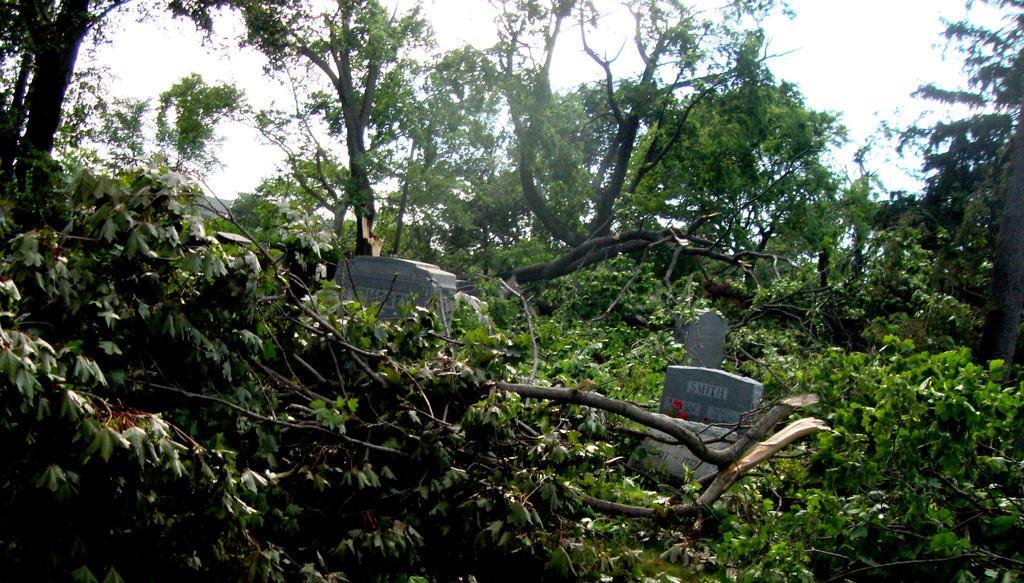Describe this image in one or two sentences. In this picture, we can see trees, graves, and the sky. 